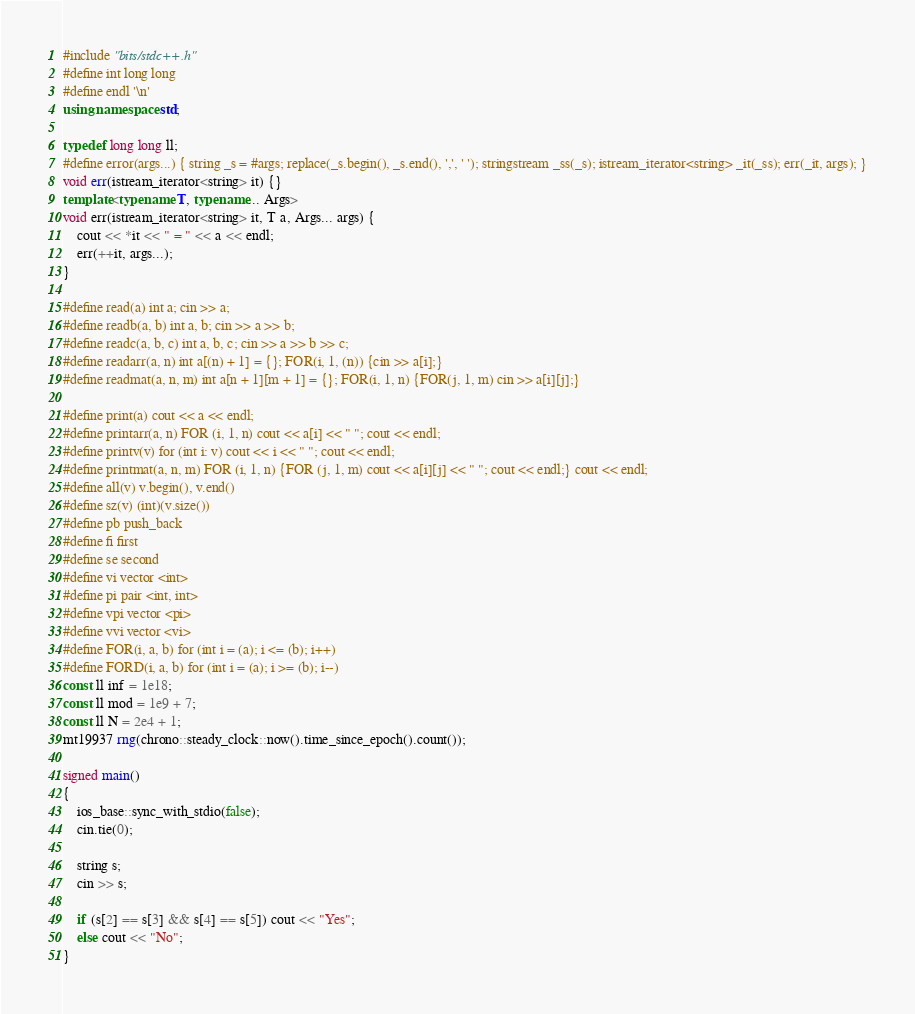<code> <loc_0><loc_0><loc_500><loc_500><_C++_>#include "bits/stdc++.h"
#define int long long
#define endl '\n'
using namespace std;
 
typedef long long ll;
#define error(args...) { string _s = #args; replace(_s.begin(), _s.end(), ',', ' '); stringstream _ss(_s); istream_iterator<string> _it(_ss); err(_it, args); }
void err(istream_iterator<string> it) {}
template<typename T, typename... Args>
void err(istream_iterator<string> it, T a, Args... args) {
	cout << *it << " = " << a << endl;
	err(++it, args...);
}
 
#define read(a) int a; cin >> a;
#define readb(a, b) int a, b; cin >> a >> b;
#define readc(a, b, c) int a, b, c; cin >> a >> b >> c;
#define readarr(a, n) int a[(n) + 1] = {}; FOR(i, 1, (n)) {cin >> a[i];}
#define readmat(a, n, m) int a[n + 1][m + 1] = {}; FOR(i, 1, n) {FOR(j, 1, m) cin >> a[i][j];}
 
#define print(a) cout << a << endl;
#define printarr(a, n) FOR (i, 1, n) cout << a[i] << " "; cout << endl;
#define printv(v) for (int i: v) cout << i << " "; cout << endl;
#define printmat(a, n, m) FOR (i, 1, n) {FOR (j, 1, m) cout << a[i][j] << " "; cout << endl;} cout << endl;
#define all(v) v.begin(), v.end()
#define sz(v) (int)(v.size())
#define pb push_back
#define fi first
#define se second
#define vi vector <int>
#define pi pair <int, int>
#define vpi vector <pi>
#define vvi vector <vi>
#define FOR(i, a, b) for (int i = (a); i <= (b); i++)
#define FORD(i, a, b) for (int i = (a); i >= (b); i--)
const ll inf = 1e18;
const ll mod = 1e9 + 7;
const ll N = 2e4 + 1;
mt19937 rng(chrono::steady_clock::now().time_since_epoch().count());
 
signed main()
{
	ios_base::sync_with_stdio(false);
	cin.tie(0);
	
	string s;
	cin >> s;
	
	if (s[2] == s[3] && s[4] == s[5]) cout << "Yes";
	else cout << "No";
}







</code> 